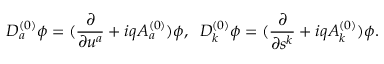<formula> <loc_0><loc_0><loc_500><loc_500>D _ { a } ^ { ( 0 ) } \phi = ( \frac { \partial } { \partial u ^ { a } } + i q A _ { a } ^ { ( 0 ) } ) \phi , \, D _ { k } ^ { ( 0 ) } \phi = ( \frac { \partial } { \partial s ^ { k } } + i q A _ { k } ^ { ( 0 ) } ) \phi .</formula> 